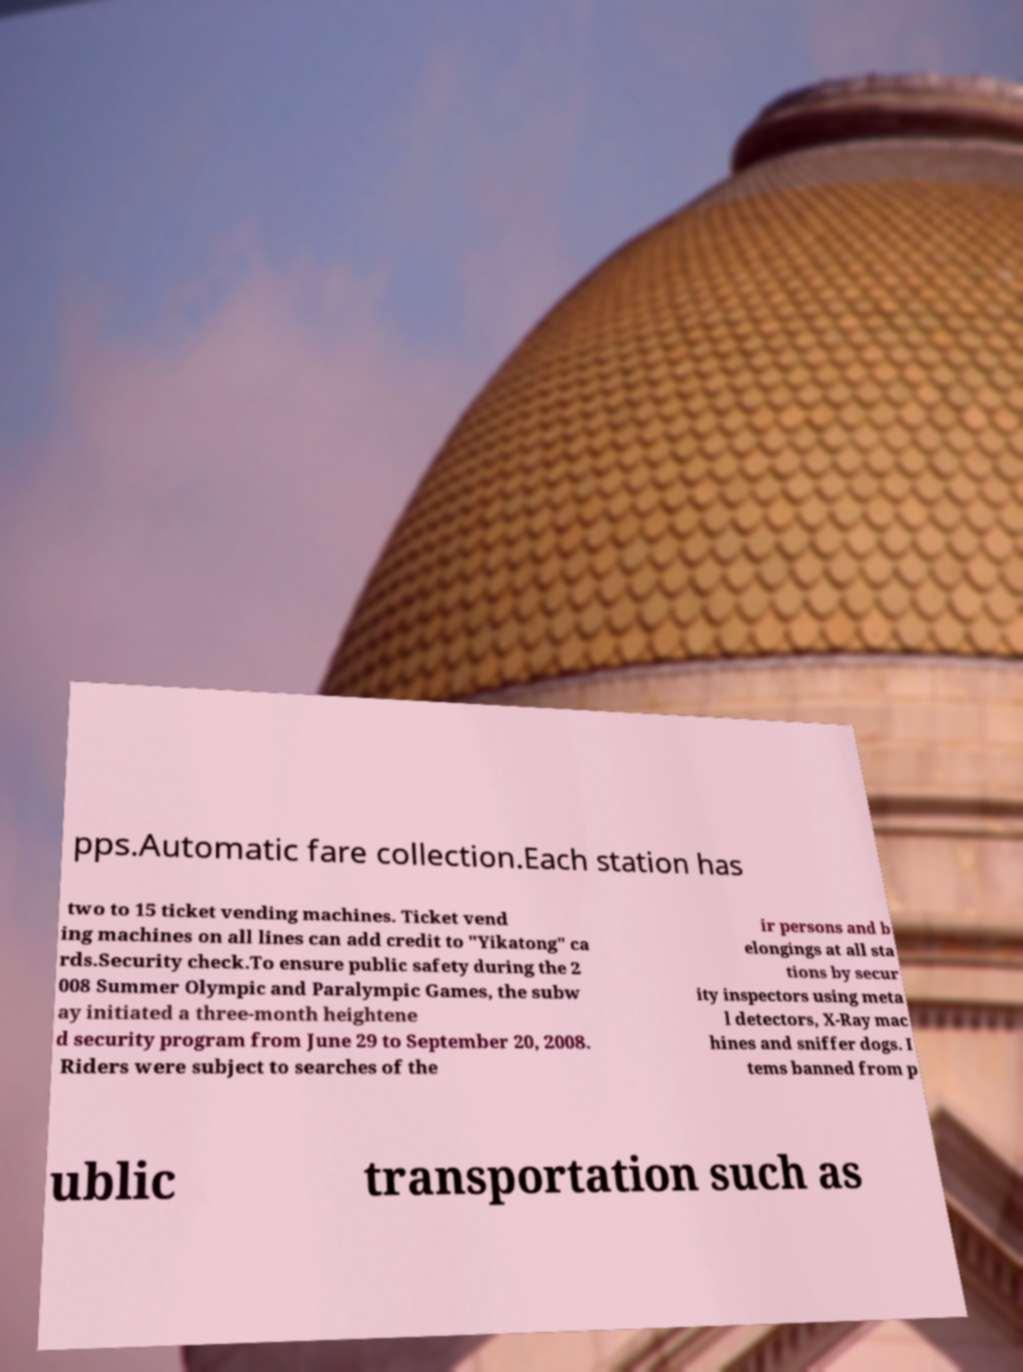Could you assist in decoding the text presented in this image and type it out clearly? pps.Automatic fare collection.Each station has two to 15 ticket vending machines. Ticket vend ing machines on all lines can add credit to "Yikatong" ca rds.Security check.To ensure public safety during the 2 008 Summer Olympic and Paralympic Games, the subw ay initiated a three-month heightene d security program from June 29 to September 20, 2008. Riders were subject to searches of the ir persons and b elongings at all sta tions by secur ity inspectors using meta l detectors, X-Ray mac hines and sniffer dogs. I tems banned from p ublic transportation such as 